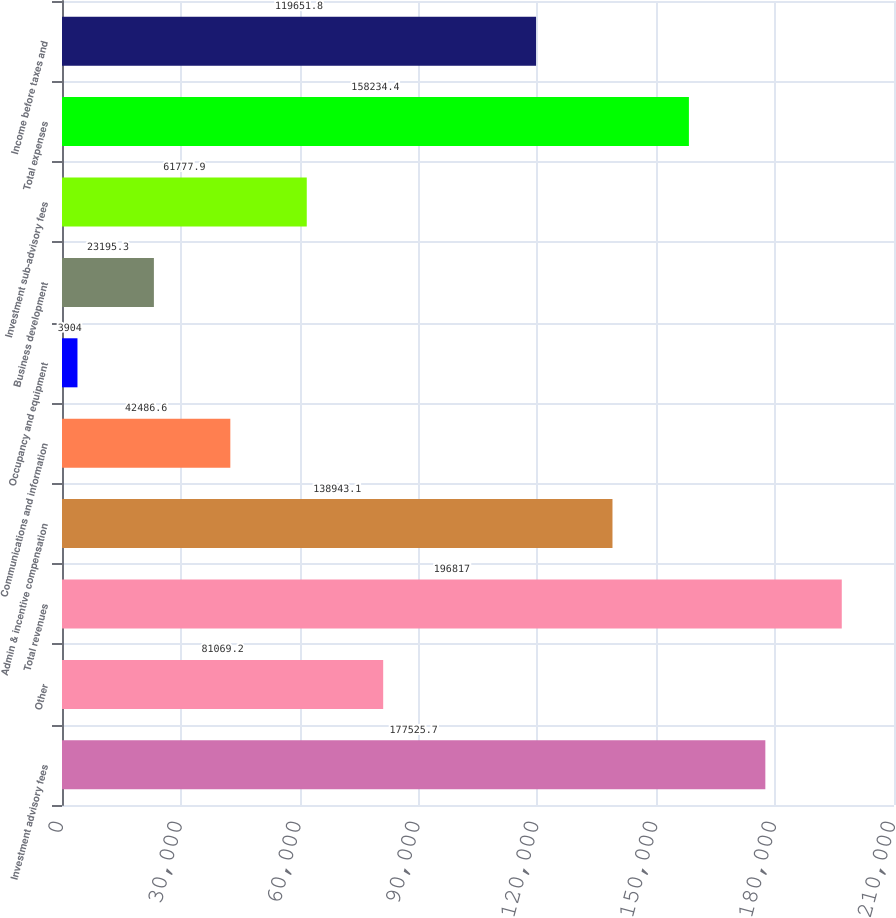<chart> <loc_0><loc_0><loc_500><loc_500><bar_chart><fcel>Investment advisory fees<fcel>Other<fcel>Total revenues<fcel>Admin & incentive compensation<fcel>Communications and information<fcel>Occupancy and equipment<fcel>Business development<fcel>Investment sub-advisory fees<fcel>Total expenses<fcel>Income before taxes and<nl><fcel>177526<fcel>81069.2<fcel>196817<fcel>138943<fcel>42486.6<fcel>3904<fcel>23195.3<fcel>61777.9<fcel>158234<fcel>119652<nl></chart> 